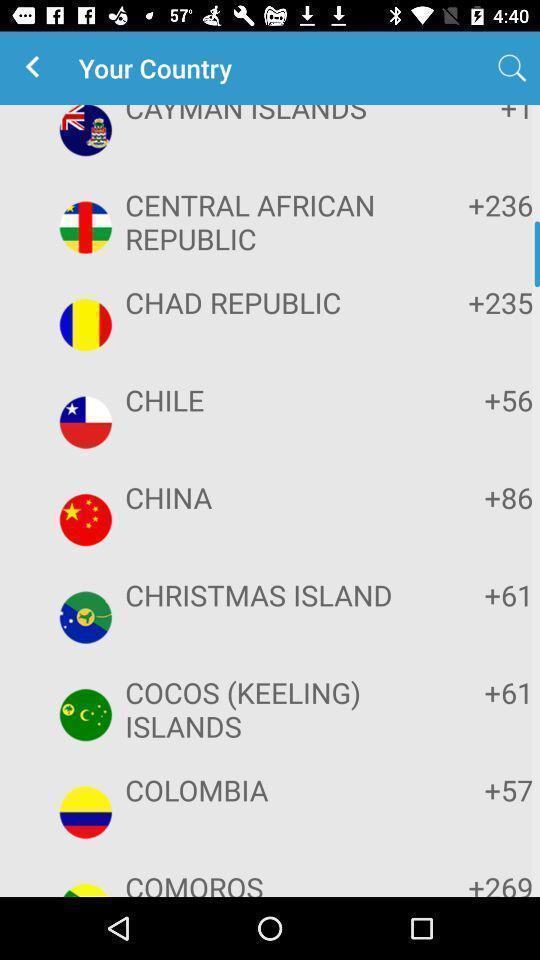Explain what's happening in this screen capture. Page for searching country of a communication app. 